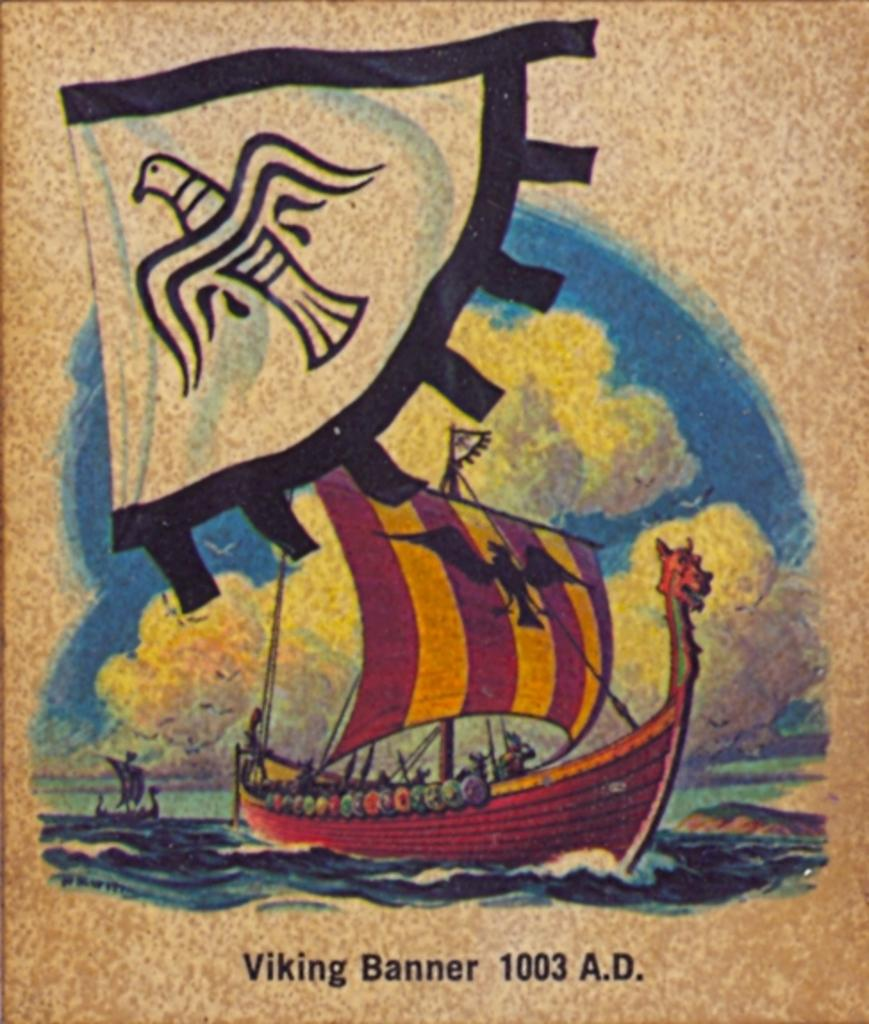<image>
Render a clear and concise summary of the photo. Poster showing a ship on the front and the words "Viking Banner". 